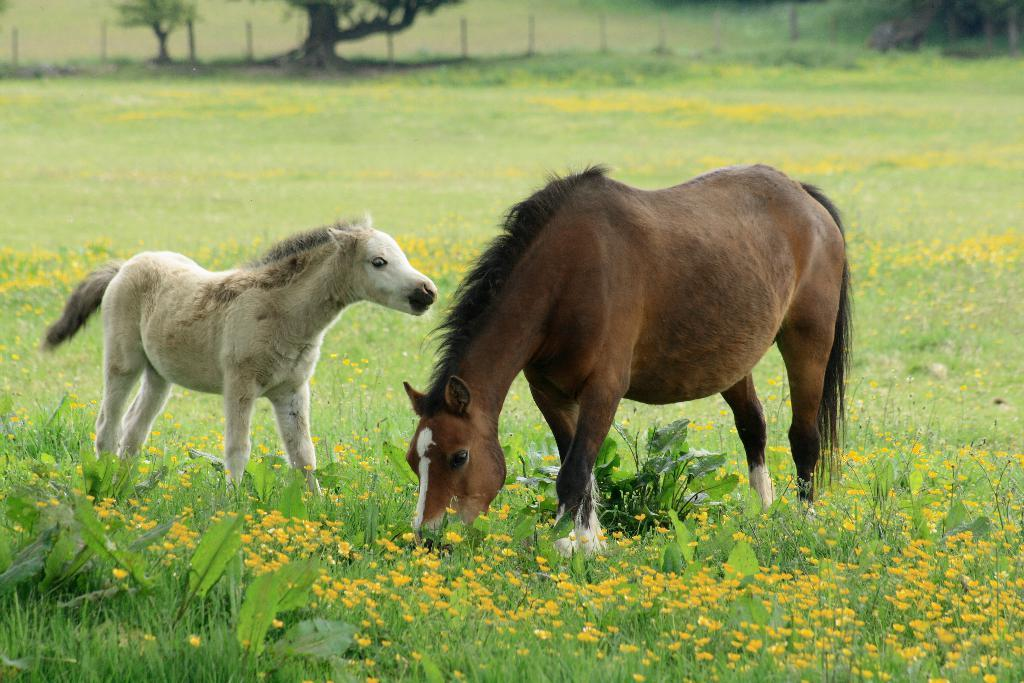What animals can be seen in the image? There is a horse and a foal in the image. Where are the horse and the foal located? Both the horse and the foal are on the grass in the image. What type of vegetation is visible in the image? Plants, flowers, and trees are present in the image. Can you see the geese kissing on the scale in the image? There are no geese, kissing, or scales present in the image. 